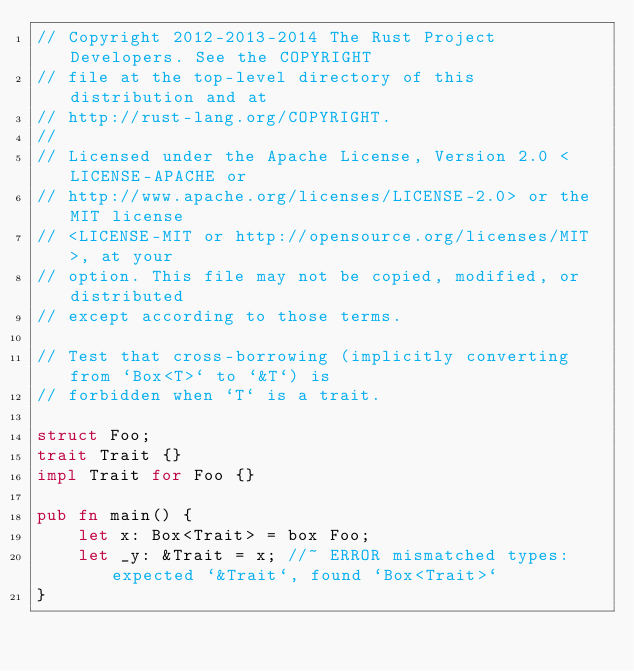Convert code to text. <code><loc_0><loc_0><loc_500><loc_500><_Rust_>// Copyright 2012-2013-2014 The Rust Project Developers. See the COPYRIGHT
// file at the top-level directory of this distribution and at
// http://rust-lang.org/COPYRIGHT.
//
// Licensed under the Apache License, Version 2.0 <LICENSE-APACHE or
// http://www.apache.org/licenses/LICENSE-2.0> or the MIT license
// <LICENSE-MIT or http://opensource.org/licenses/MIT>, at your
// option. This file may not be copied, modified, or distributed
// except according to those terms.

// Test that cross-borrowing (implicitly converting from `Box<T>` to `&T`) is
// forbidden when `T` is a trait.

struct Foo;
trait Trait {}
impl Trait for Foo {}

pub fn main() {
    let x: Box<Trait> = box Foo;
    let _y: &Trait = x; //~ ERROR mismatched types: expected `&Trait`, found `Box<Trait>`
}

</code> 